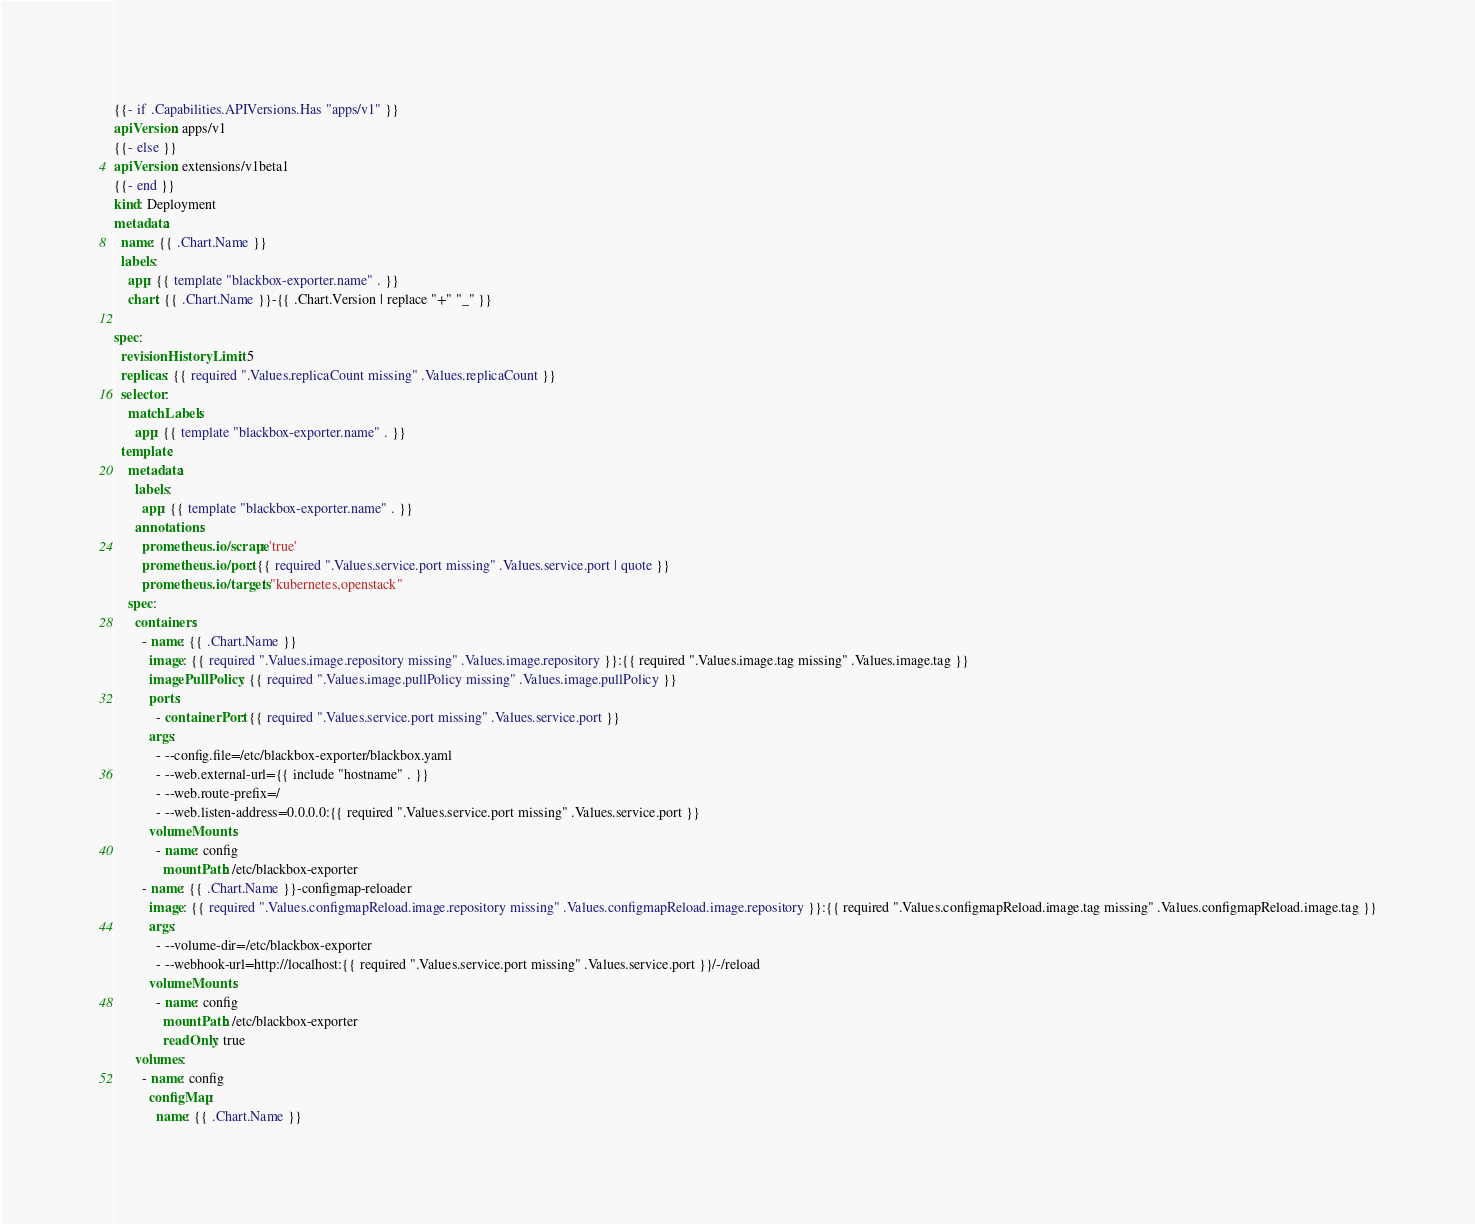<code> <loc_0><loc_0><loc_500><loc_500><_YAML_>{{- if .Capabilities.APIVersions.Has "apps/v1" }}
apiVersion: apps/v1
{{- else }}
apiVersion: extensions/v1beta1
{{- end }}
kind: Deployment
metadata:
  name: {{ .Chart.Name }}
  labels:
    app: {{ template "blackbox-exporter.name" . }}
    chart: {{ .Chart.Name }}-{{ .Chart.Version | replace "+" "_" }}

spec:
  revisionHistoryLimit: 5
  replicas: {{ required ".Values.replicaCount missing" .Values.replicaCount }}
  selector:
    matchLabels:
      app: {{ template "blackbox-exporter.name" . }}
  template:
    metadata:
      labels:
        app: {{ template "blackbox-exporter.name" . }}
      annotations:
        prometheus.io/scrape: 'true'
        prometheus.io/port: {{ required ".Values.service.port missing" .Values.service.port | quote }}
        prometheus.io/targets: "kubernetes,openstack"
    spec:
      containers:
        - name: {{ .Chart.Name }}
          image: {{ required ".Values.image.repository missing" .Values.image.repository }}:{{ required ".Values.image.tag missing" .Values.image.tag }}
          imagePullPolicy: {{ required ".Values.image.pullPolicy missing" .Values.image.pullPolicy }}
          ports:
            - containerPort: {{ required ".Values.service.port missing" .Values.service.port }}
          args:
            - --config.file=/etc/blackbox-exporter/blackbox.yaml
            - --web.external-url={{ include "hostname" . }}
            - --web.route-prefix=/
            - --web.listen-address=0.0.0.0:{{ required ".Values.service.port missing" .Values.service.port }}
          volumeMounts:
            - name: config
              mountPath: /etc/blackbox-exporter
        - name: {{ .Chart.Name }}-configmap-reloader
          image: {{ required ".Values.configmapReload.image.repository missing" .Values.configmapReload.image.repository }}:{{ required ".Values.configmapReload.image.tag missing" .Values.configmapReload.image.tag }}
          args:
            - --volume-dir=/etc/blackbox-exporter
            - --webhook-url=http://localhost:{{ required ".Values.service.port missing" .Values.service.port }}/-/reload
          volumeMounts:
            - name: config
              mountPath: /etc/blackbox-exporter
              readOnly: true
      volumes:
        - name: config
          configMap:
            name: {{ .Chart.Name }}
</code> 